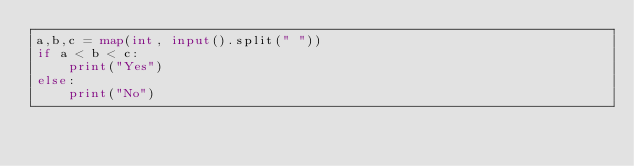Convert code to text. <code><loc_0><loc_0><loc_500><loc_500><_Python_>a,b,c = map(int, input().split(" "))
if a < b < c:
    print("Yes")
else:
    print("No")
</code> 